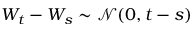<formula> <loc_0><loc_0><loc_500><loc_500>W _ { t } - W _ { s } \sim { \mathcal { N } } ( 0 , t - s )</formula> 